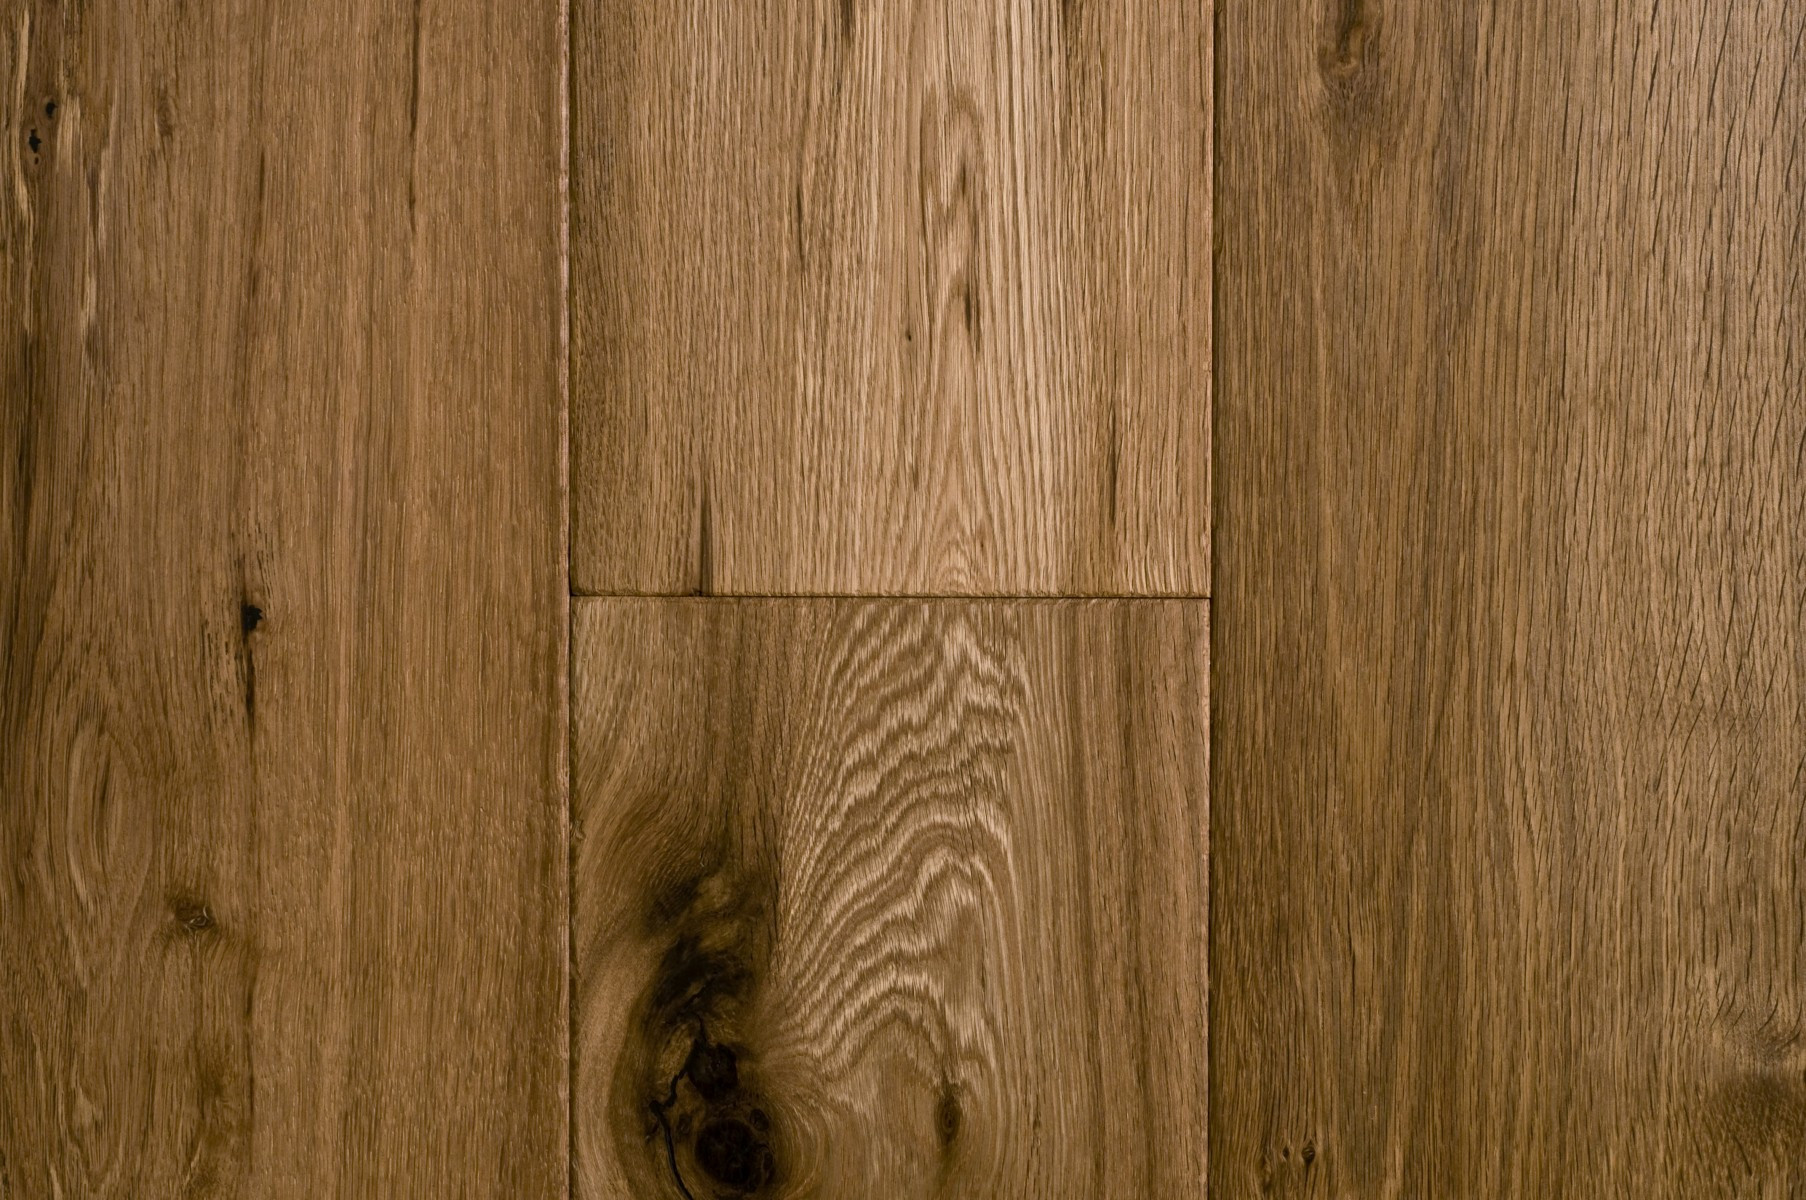Could you suggest the best maintenance practices to preserve the quality of this oak flooring? Maintaining oak flooring involves regular sweeping or vacuuming to remove dirt and grit that can scratch the surface. It's also beneficial to mop the floor periodically with a slightly damp mop using a cleaner specifically formulated for hardwood. To protect the wood, avoid using excessive water and harsh cleaning agents. Applying a suitable hardwood polish or wax annually can also help preserve the floor's natural beauty and protect it from wear and tear. Additionally, using rugs in high-traffic areas and felt pads under furniture legs can prevent scratches and damage. 